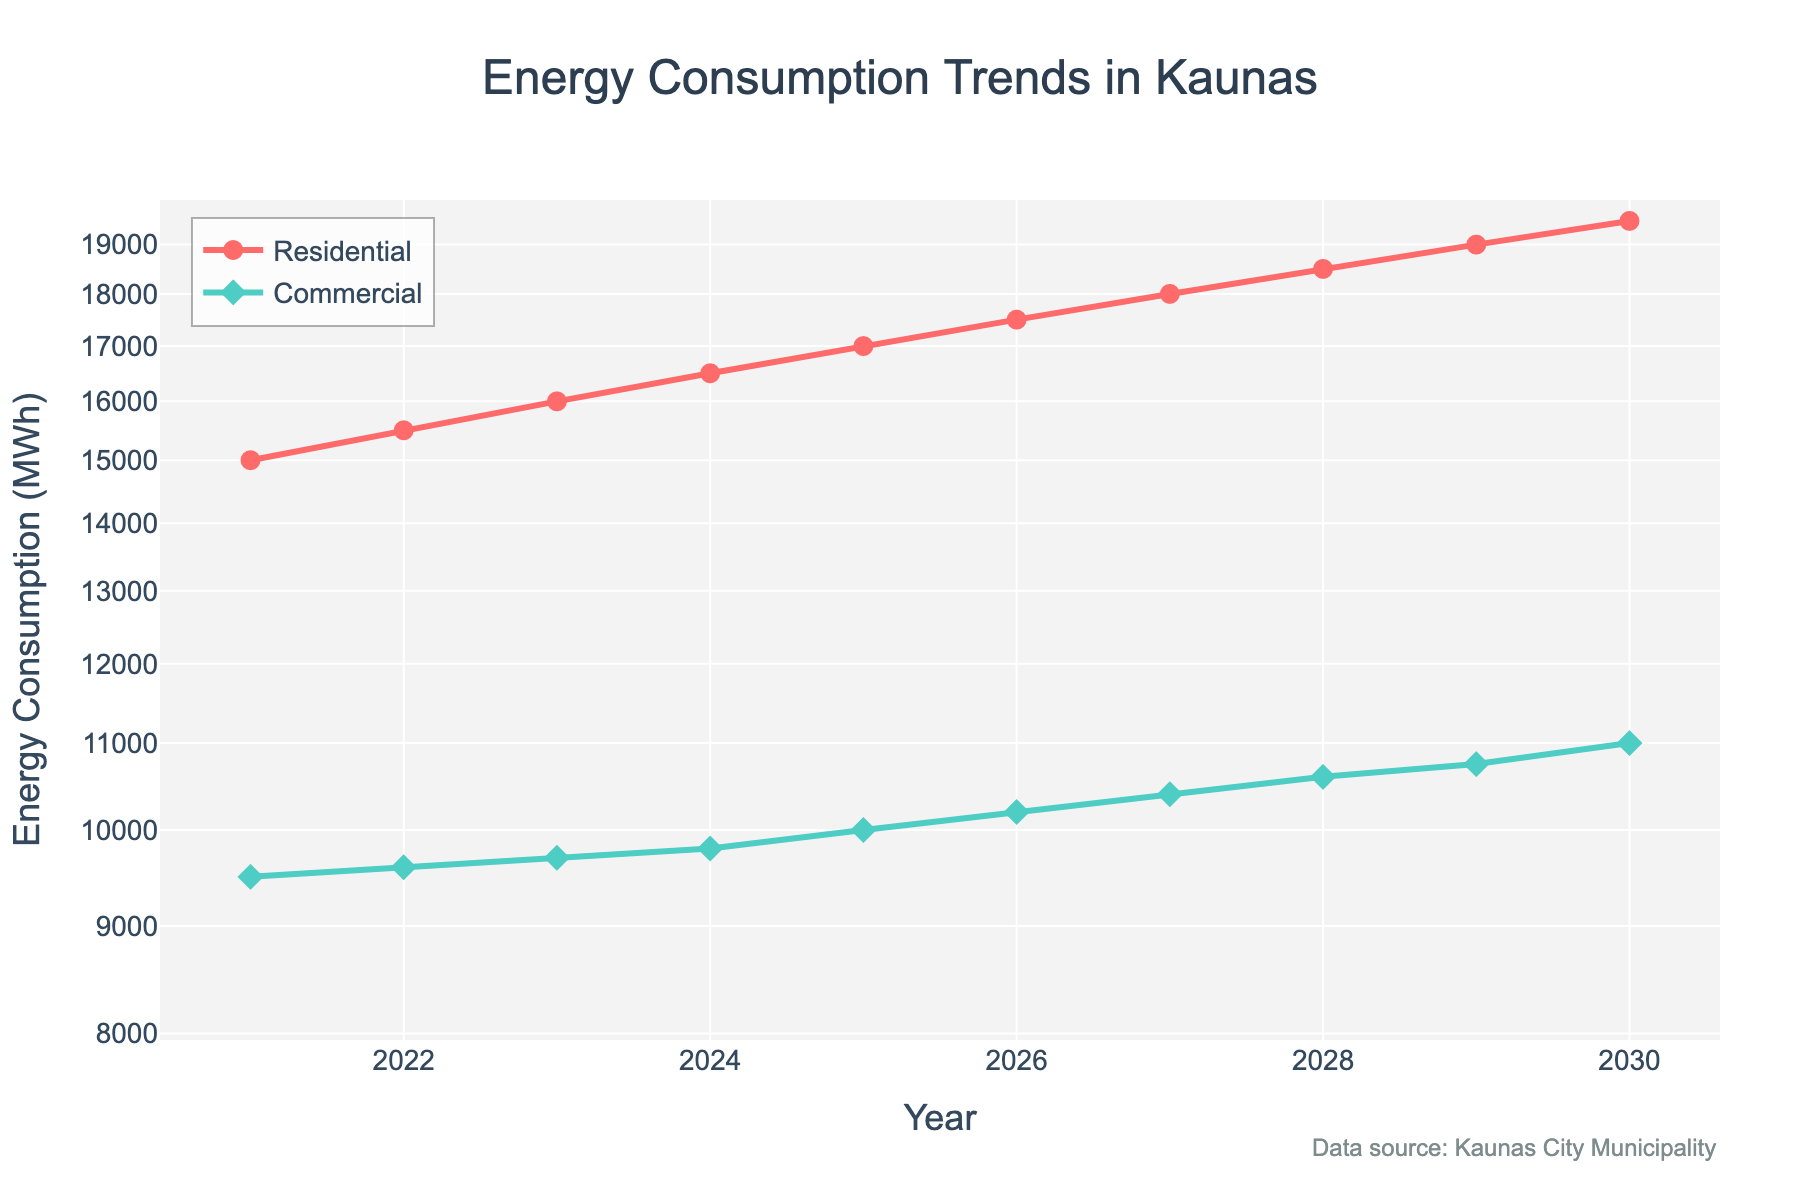What is the title of the plot? The title of the plot is positioned at the top and is centrally aligned. The title text is "Energy Consumption Trends in Kaunas".
Answer: Energy Consumption Trends in Kaunas Which sector showed higher energy consumption in 2022, Residential or Commercial? Look at the value for both sectors in the year 2022. The Residential consumption is 15,500 MWh, and the Commercial consumption is 9,600 MWh. Residential consumption is higher.
Answer: Residential What is the color used for the Residential consumption line? The color for the Residential consumption line is visually identifiable as a shade of red.
Answer: Red What trend can be observed for both sectors' energy consumption over the years? Both lines visually indicate a consistent year-on-year increase in energy consumption from 2021 to 2030. This is evident as both the Residential and Commercial lines slope upwards year over year.
Answer: Upward trend How much more energy did the Residential sector consume compared to the Commercial sector in 2025? To find the difference, subtract the Commercial consumption from the Residential consumption for the year 2025. Residential is 17,000 MWh, and Commercial is 10,000 MWh, giving 17,000 - 10,000 = 7,000 MWh.
Answer: 7,000 MWh What is the consistency of growth in energy consumption for either sector? The consistent spacing between data points year over year indicates steady growth for both sectors.
Answer: Steady growth In which year did the Residential consumption reach 18,000 MWh? Look for the year where the Residential line reaches 18,000 MWh on the plot. The year is 2027.
Answer: 2027 By how much did the Commercial energy consumption increase from 2021 to 2030? Subtract the Commercial energy consumption in 2021 from that in 2030. The difference is 11,000 MWh - 9,500 MWh = 1,500 MWh.
Answer: 1,500 MWh Is the scale of the y-axis linear or logarithmic, and how can you tell? The y-axis indicates log-scale due to the regular spacing of values that increase multiplicatively rather than additively. This information is also specified in the plot details.
Answer: Logarithmic Which year has the largest gap between Residential and Commercial energy consumption? To find the largest gap, look at each year's difference: 2021 (5,500 MWh), 2022 (5,900 MWh), 2023 (6,300 MWh), 2024 (6,700 MWh), 2025 (7,000 MWh), 2026 (7,300 MWh), 2027 (7,600 MWh), 2028 (7,900 MWh), 2029 (8,150 MWh), 2030 (8,500 MWh). The largest gap is in 2030.
Answer: 2030 